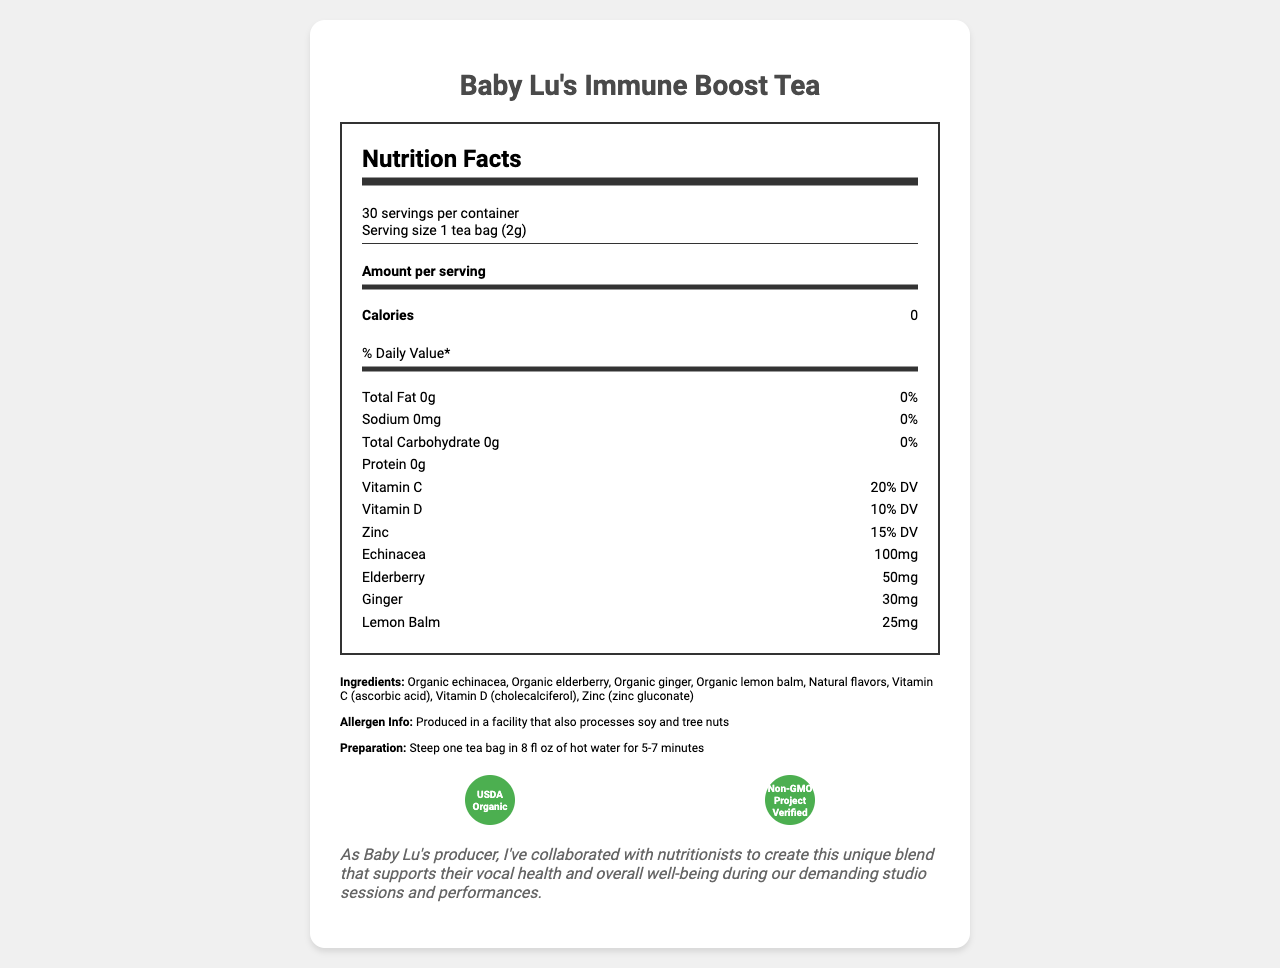what is the serving size for Baby Lu's Immune Boost Tea? The document specifies that the serving size is 1 tea bag, which equals 2 grams.
Answer: 1 tea bag (2g) how many servings are there per container? The document notes that there are 30 servings per container.
Answer: 30 how much Vitamin C is in one serving of the tea? The document states that one serving provides 20% of the daily value of Vitamin C.
Answer: 20% DV how many calories are there per serving? The document states that each serving has 0 calories.
Answer: 0 list the main herbs included in Baby Lu's Immune Boost Tea The document lists organic echinacea, organic elderberry, organic ginger, and organic lemon balm as ingredients.
Answer: Echinacea, Elderberry, Ginger, Lemon Balm which vitamin has the highest Daily Value percentage in one serving? A) Vitamin C B) Vitamin D C) Zinc D) Vitamin B12 The document shows that Vitamin C has the highest percentage at 20% DV, followed by Zinc at 15% DV and then Vitamin D at 10% DV.
Answer: A) Vitamin C who is the manufacturer of this herbal tea blend? A) Starlight Wellness Labs B) Baby Lu's Nutrition C) Healthy Herbs Co. The document indicates that the manufacturer is Starlight Wellness Labs.
Answer: A) Starlight Wellness Labs does the product have any calories? The document explicitly states that the product has 0 calories.
Answer: No is the tea produced in an allergen-free facility? The document mentions that the tea is produced in a facility that also processes soy and tree nuts.
Answer: No summarize the main purpose of Baby Lu's Immune Boost Tea. The document describes the tea as a specially formulated herbal blend designed to boost and support Baby Lu's immune system during recording sessions and tours. It includes vitamins, organic ingredients, and offers health benefits like immune support and antioxidant properties.
Answer: To support Baby Lu's immune system, vocal health, and overall well-being during demanding studio sessions and performances. It contains various herbal ingredients and vitamins to boost immunity and health. what is the exact amount of Echinacea in one serving? The document lists that each serving contains 100mg of Echinacea.
Answer: 100mg which certifications does the product have? The document shows that the product is certified USDA Organic and Non-GMO Project Verified.
Answer: USDA Organic, Non-GMO Project Verified how should you prepare this tea? A) Boil for 10 minutes B) Steep in cold water C) Steep in hot water for 5-7 minutes D) Microwave for 2 minutes The document provides preparation instructions stating to steep one tea bag in 8 fl oz of hot water for 5-7 minutes.
Answer: C) Steep in hot water for 5-7 minutes what is the product name? The document clearly states that the product name is Baby Lu's Immune Boost Tea.
Answer: Baby Lu's Immune Boost Tea does the product contain Vitamin B12? The document lists the specific vitamins with their percentages but does not mention Vitamin B12. Therefore, the presence of Vitamin B12 cannot be determined from the given information.
Answer: Cannot be determined 